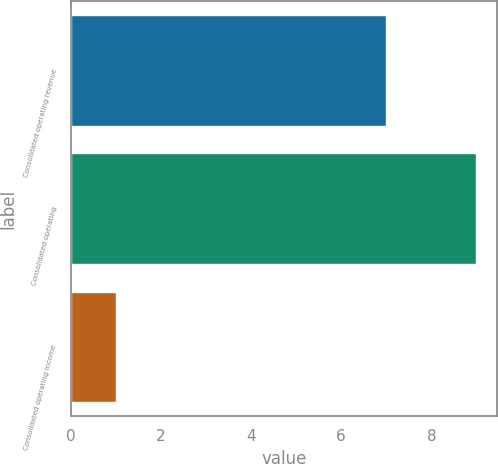<chart> <loc_0><loc_0><loc_500><loc_500><bar_chart><fcel>Consolidated operating revenue<fcel>Consolidated operating<fcel>Consolidated operating income<nl><fcel>7<fcel>9<fcel>1<nl></chart> 